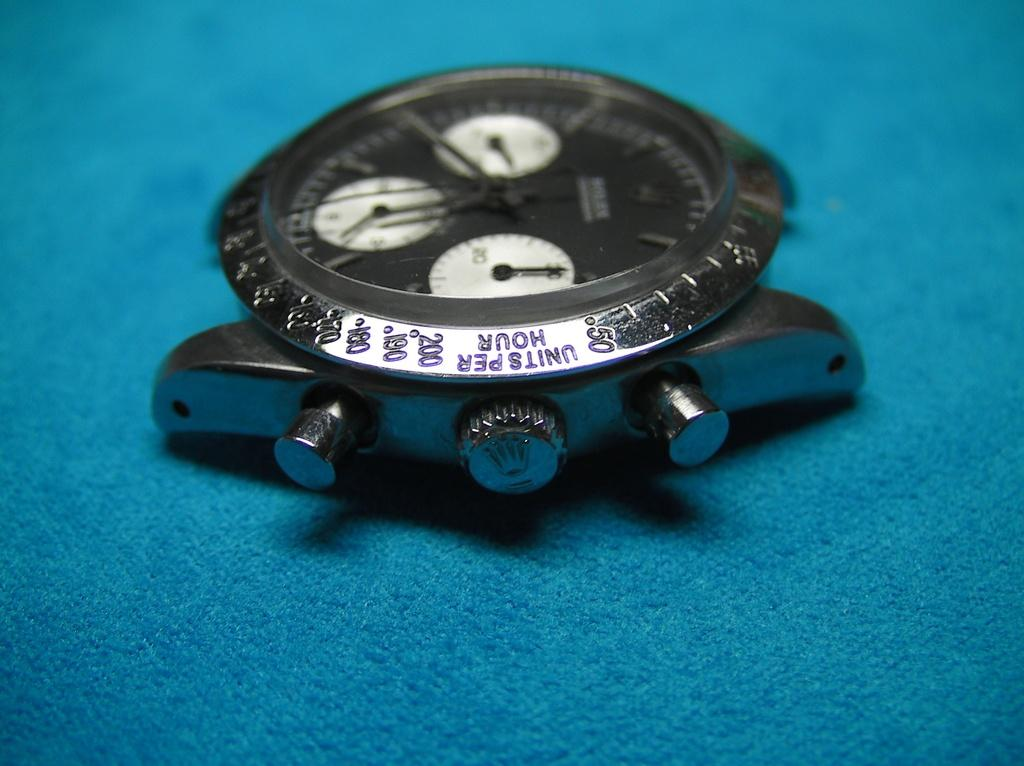Provide a one-sentence caption for the provided image. A silver watch with numbers around the outter edge with the word units per hour engraved at the edge. 